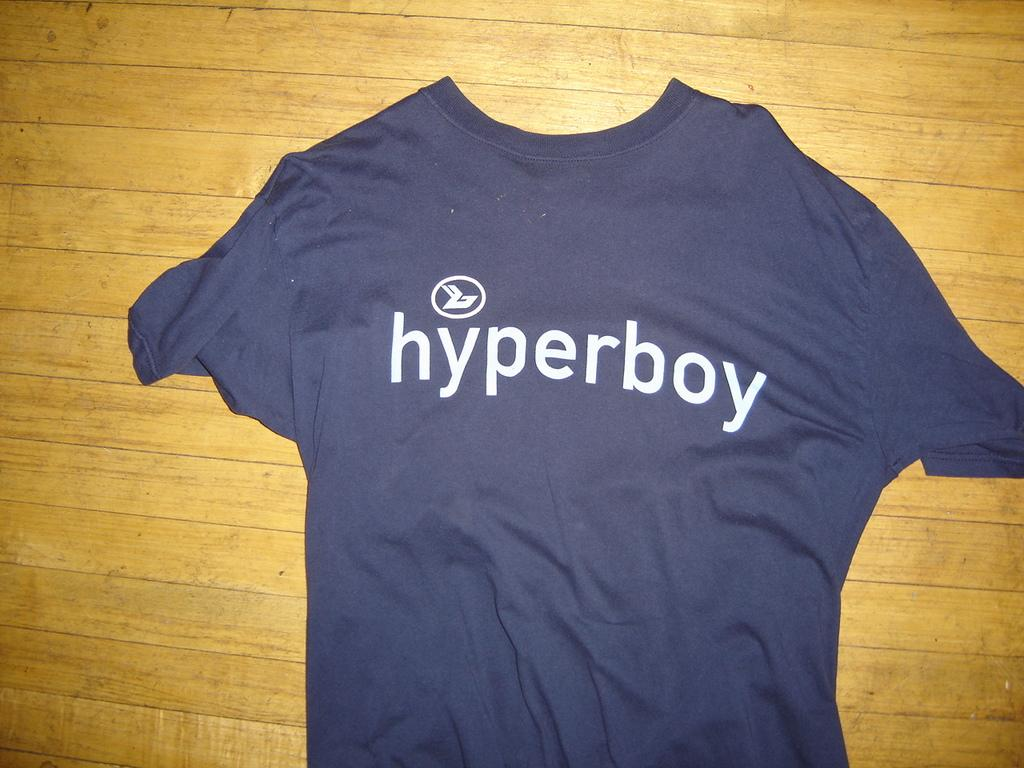Provide a one-sentence caption for the provided image. A small navy shirt reading hyperboy lying on a table or floor. 